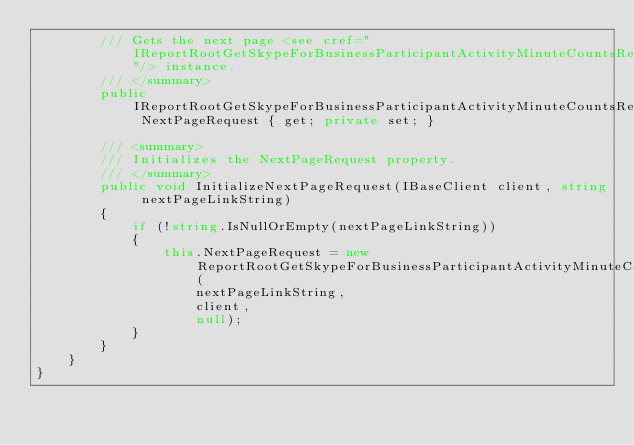<code> <loc_0><loc_0><loc_500><loc_500><_C#_>        /// Gets the next page <see cref="IReportRootGetSkypeForBusinessParticipantActivityMinuteCountsRequest"/> instance.
        /// </summary>
        public IReportRootGetSkypeForBusinessParticipantActivityMinuteCountsRequest NextPageRequest { get; private set; }

        /// <summary>
        /// Initializes the NextPageRequest property.
        /// </summary>
        public void InitializeNextPageRequest(IBaseClient client, string nextPageLinkString)
        {
            if (!string.IsNullOrEmpty(nextPageLinkString))
            {
                this.NextPageRequest = new ReportRootGetSkypeForBusinessParticipantActivityMinuteCountsRequest(
                    nextPageLinkString,
                    client,
                    null);
            }
        }
    }
}
</code> 